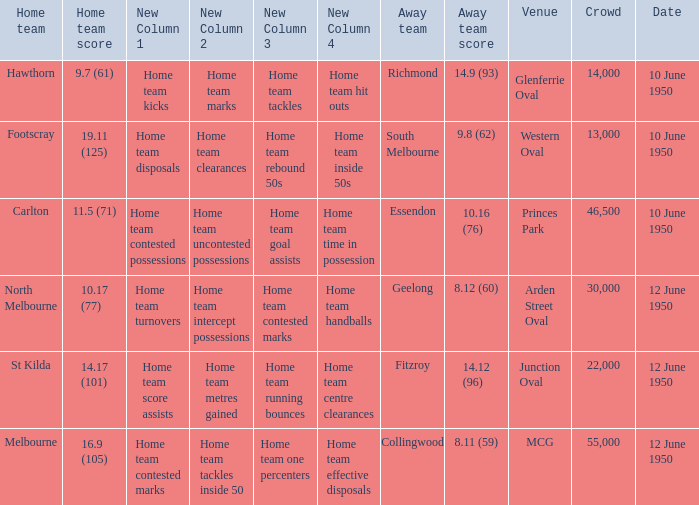Who was the away team when the VFL played at MCG? Collingwood. 